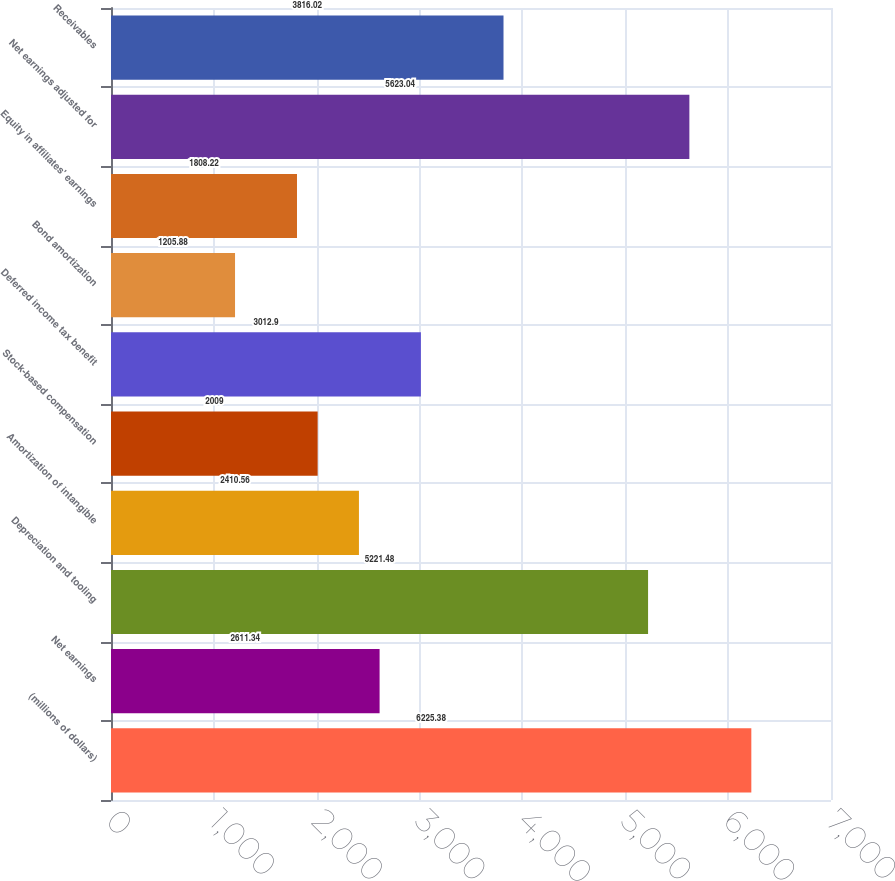Convert chart to OTSL. <chart><loc_0><loc_0><loc_500><loc_500><bar_chart><fcel>(millions of dollars)<fcel>Net earnings<fcel>Depreciation and tooling<fcel>Amortization of intangible<fcel>Stock-based compensation<fcel>Deferred income tax benefit<fcel>Bond amortization<fcel>Equity in affiliates' earnings<fcel>Net earnings adjusted for<fcel>Receivables<nl><fcel>6225.38<fcel>2611.34<fcel>5221.48<fcel>2410.56<fcel>2009<fcel>3012.9<fcel>1205.88<fcel>1808.22<fcel>5623.04<fcel>3816.02<nl></chart> 